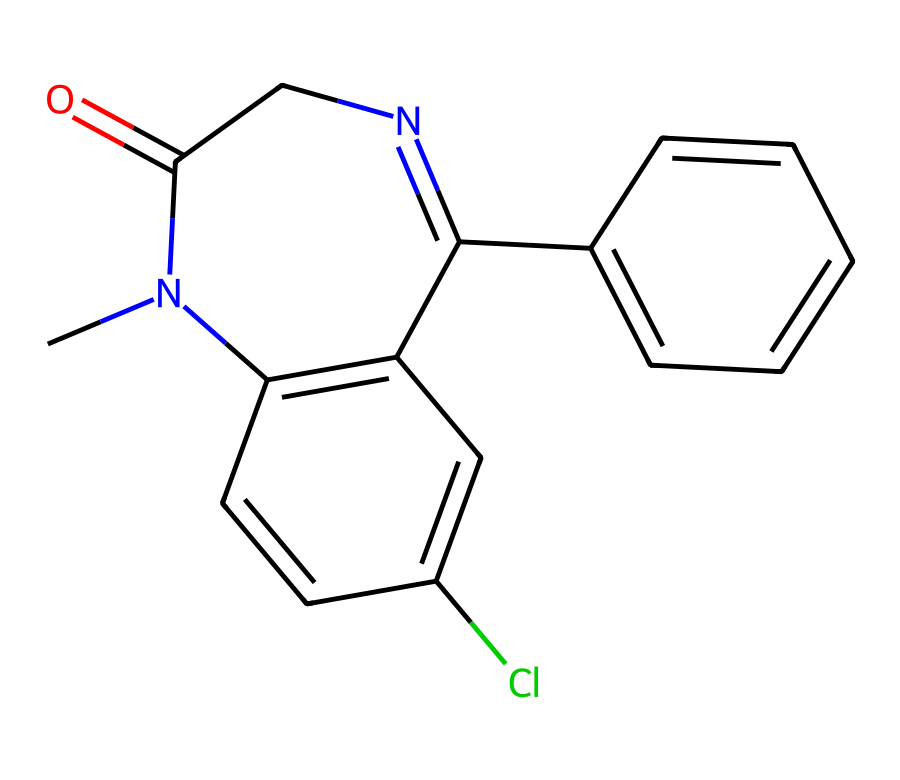What is the molecular formula of diazepam? To determine the molecular formula, count the number of each type of atom present in the SMILES representation. There are 16 carbon atoms (C), 14 hydrogen atoms (H), 2 nitrogen atoms (N), 1 oxygen atom (O), and 1 chlorine atom (Cl). Thus, the molecular formula is C16H14ClN2O.
Answer: C16H14ClN2O How many rings are present in diazepam's structure? By examining the SMILES, identify the cyclic structures. The structure contains two fused rings (the benzene rings and the diazepine ring), leading to a total of 2 rings.
Answer: 2 What functional groups are present in diazepam? Identify the functional groups from the SMILES notation. The notable groups are an amide (C(=O)N) and a chlorine substituent (Cl). Therefore, the relevant functional groups are an amide group and a chloro-substituent.
Answer: amide, chloro What is the total number of nitrogen atoms in diazepam? Count the nitrogen atoms present in the SMILES representation. There are 2 nitrogen atoms clearly indicated in the structure.
Answer: 2 Which part of diazepam’s structure is responsible for its central nervous system effect? The diazepine ring is a significant part that interacts with the GABA receptors in the brain, leading to its anxiolytic (anti-anxiety) effects. Identifying this part indicates that the diazepine structure is crucial for diazepam's functionality.
Answer: diazepine ring What is the significance of the chlorine atom in diazepam? The presence of the chlorine atom can affect the pharmacological properties of the molecule by altering its binding affinity and bioavailability. The position of chlorine in the structure contributes to the modification of its overall properties.
Answer: alters pharmacological properties 